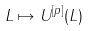<formula> <loc_0><loc_0><loc_500><loc_500>L \mapsto U ^ { [ p ] } ( L )</formula> 